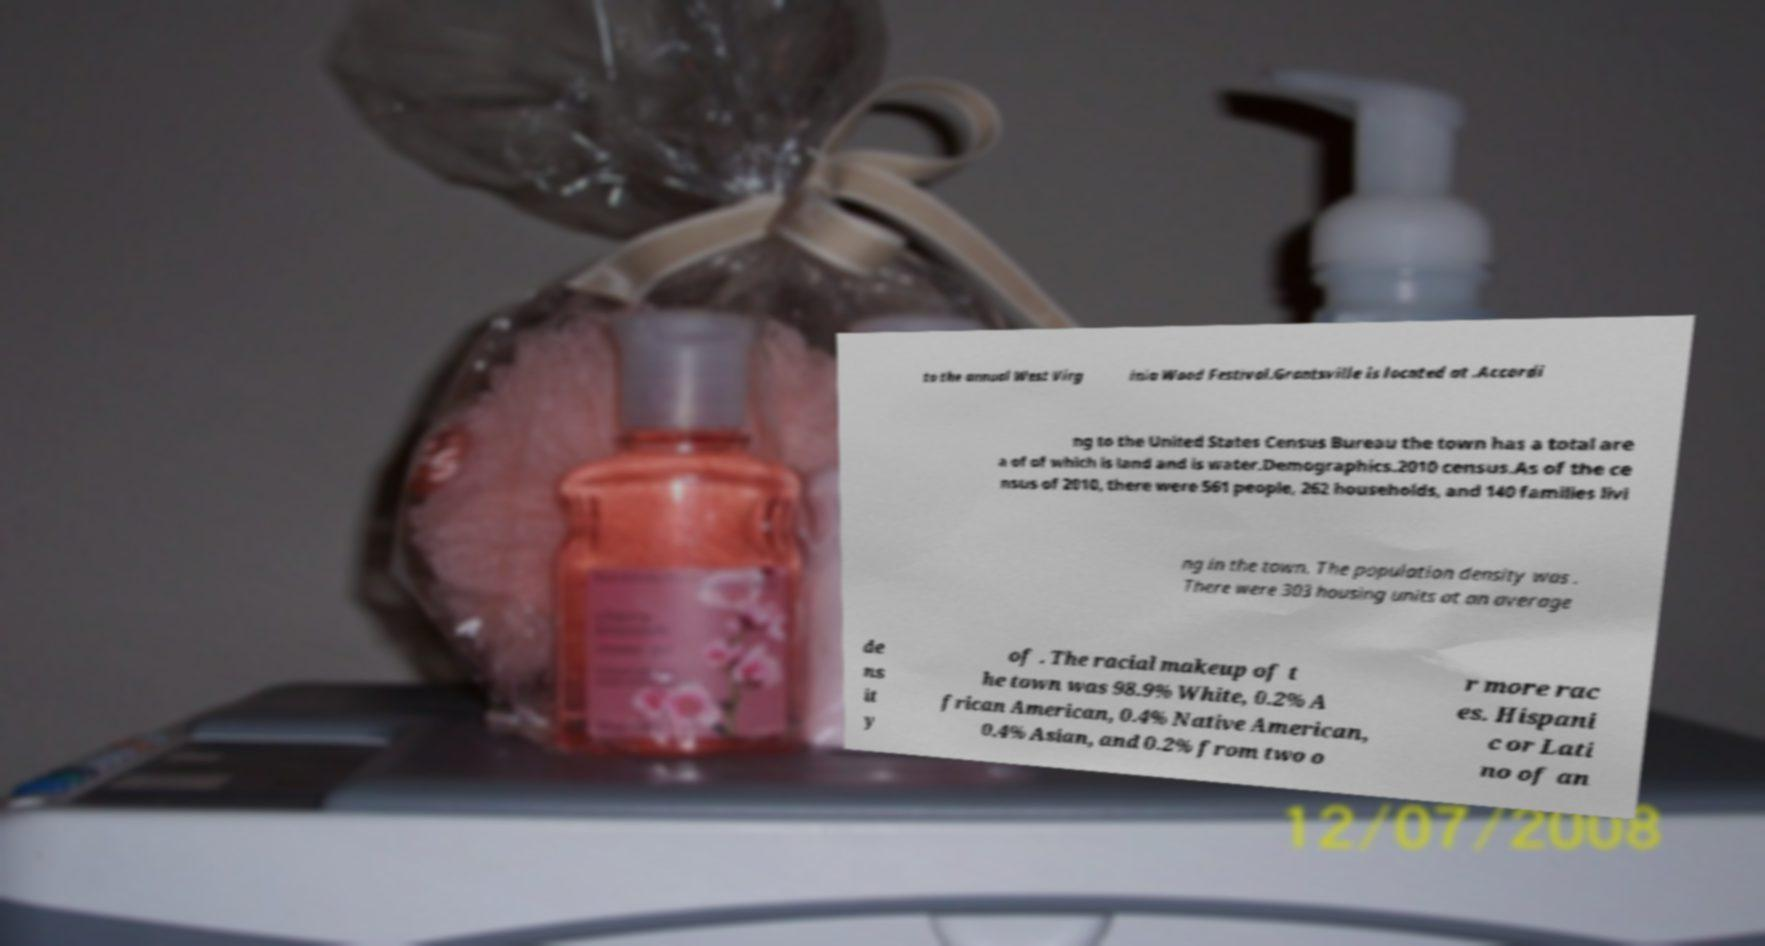Please identify and transcribe the text found in this image. to the annual West Virg inia Wood Festival.Grantsville is located at .Accordi ng to the United States Census Bureau the town has a total are a of of which is land and is water.Demographics.2010 census.As of the ce nsus of 2010, there were 561 people, 262 households, and 140 families livi ng in the town. The population density was . There were 303 housing units at an average de ns it y of . The racial makeup of t he town was 98.9% White, 0.2% A frican American, 0.4% Native American, 0.4% Asian, and 0.2% from two o r more rac es. Hispani c or Lati no of an 